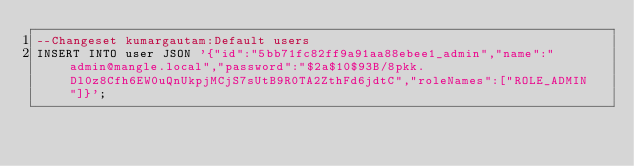<code> <loc_0><loc_0><loc_500><loc_500><_SQL_>--Changeset kumargautam:Default users
INSERT INTO user JSON '{"id":"5bb71fc82ff9a91aa88ebee1_admin","name":"admin@mangle.local","password":"$2a$10$93B/8pkk.Dl0z8Cfh6EW0uQnUkpjMCjS7sUtB9R0TA2ZthFd6jdtC","roleNames":["ROLE_ADMIN"]}';</code> 